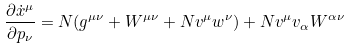<formula> <loc_0><loc_0><loc_500><loc_500>\frac { \partial \dot { x } ^ { \mu } } { \partial p _ { \nu } } = N ( g ^ { \mu \nu } + W ^ { \mu \nu } + N v ^ { \mu } w ^ { \nu } ) + N v ^ { \mu } v _ { \alpha } W ^ { \alpha \nu }</formula> 